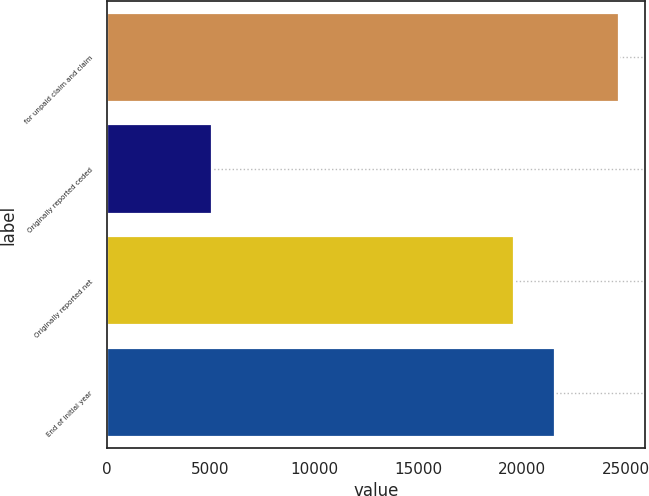Convert chart. <chart><loc_0><loc_0><loc_500><loc_500><bar_chart><fcel>for unpaid claim and claim<fcel>Originally reported ceded<fcel>Originally reported net<fcel>End of initial year<nl><fcel>24696<fcel>5075<fcel>19621<fcel>21583.1<nl></chart> 